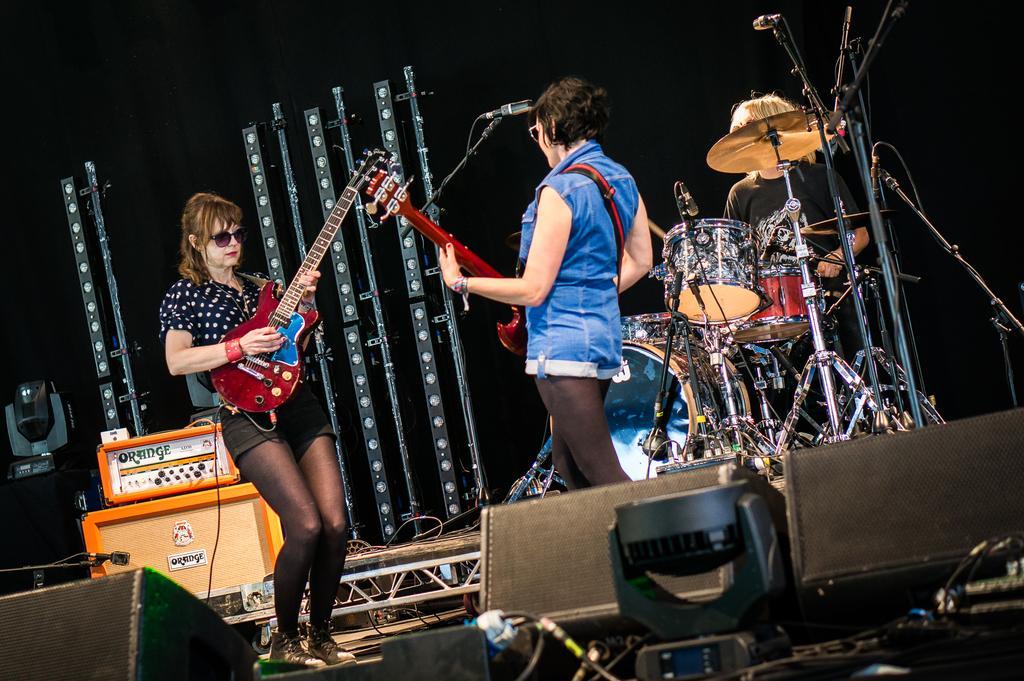Can you describe this image briefly? In this image, there are a few people holding some objects. We can see some musical instruments and microphones. We can see some objects on the left and some objects at the bottom. We can also see the dark background. We can see some metal objects. 